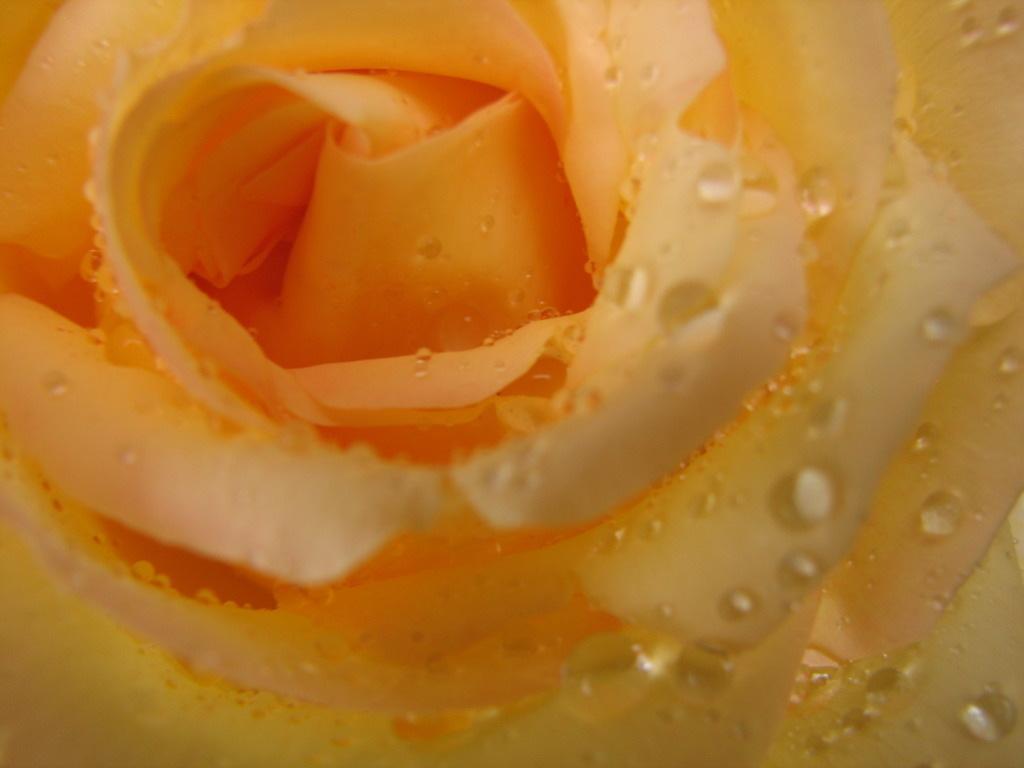Can you describe this image briefly? In this picture we can see a flower which is truncated. 